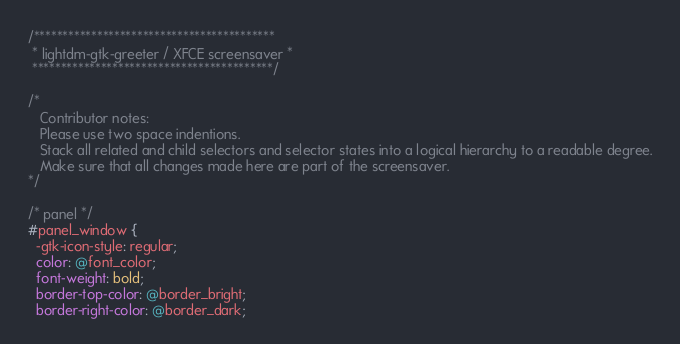Convert code to text. <code><loc_0><loc_0><loc_500><loc_500><_CSS_>/******************************************
 * lightdm-gtk-greeter / XFCE screensaver *
 ******************************************/

/*
   Contributor notes:
   Please use two space indentions.
   Stack all related and child selectors and selector states into a logical hierarchy to a readable degree.
   Make sure that all changes made here are part of the screensaver.
*/

/* panel */
#panel_window {
  -gtk-icon-style: regular; 
  color: @font_color;
  font-weight: bold;
  border-top-color: @border_bright;
  border-right-color: @border_dark;</code> 